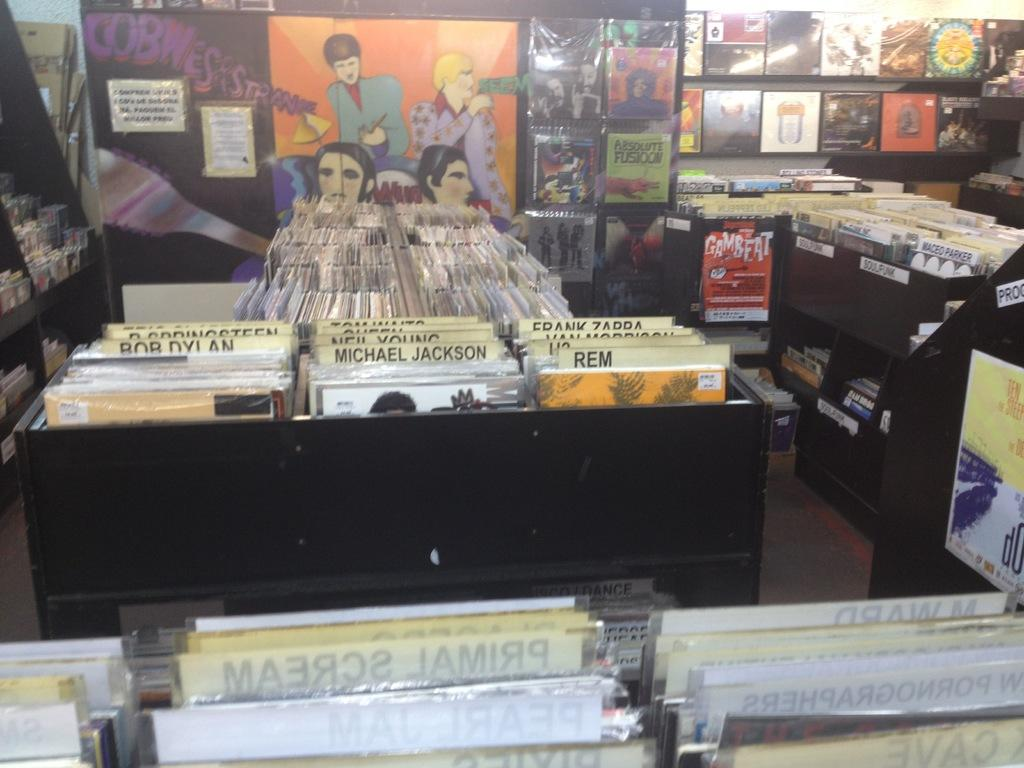What objects are visible in the image? There are compact discs in the image. How are the compact discs arranged? The compact discs are arranged in shelves. How many compact discs can be seen in the image? There are many compact discs in the image. Is there any organization or categorization of the compact discs? Yes, the compact discs are arranged according to a list of people. What else can be seen in the image? There is a wall in the image. How does the beggar in the image use the bun to get credit? There is no beggar or bun present in the image; it features compact discs arranged in shelves. 